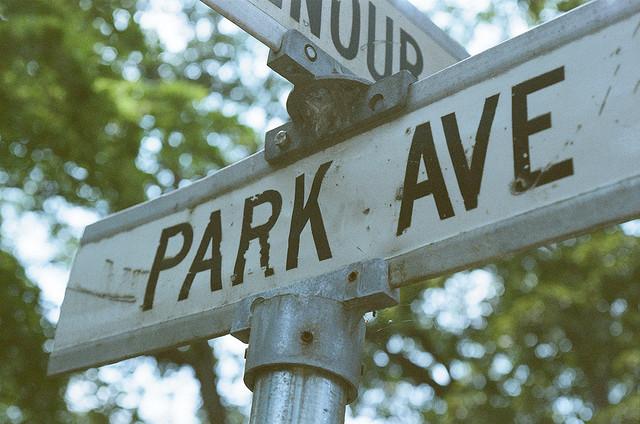What street is this sign for?
Concise answer only. Park ave. Can the name of the street on the top sign be read?
Give a very brief answer. No. Where is Park Avenue written?
Keep it brief. On sign. 